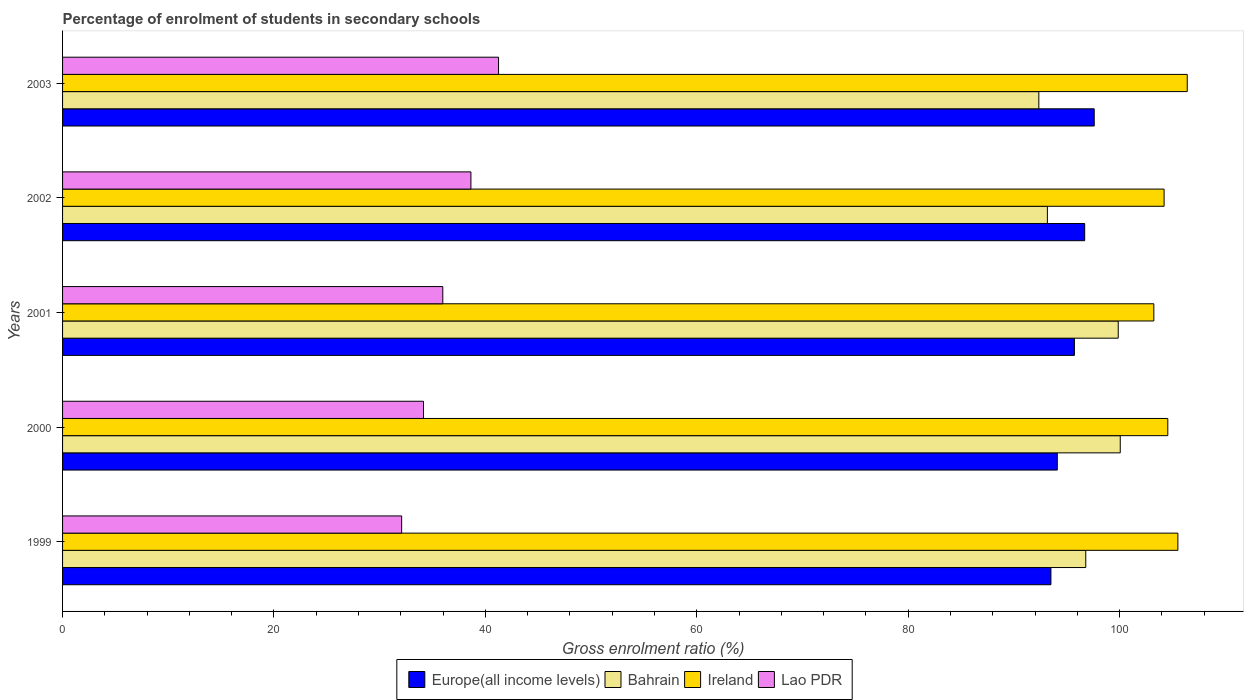How many different coloured bars are there?
Offer a terse response. 4. Are the number of bars per tick equal to the number of legend labels?
Keep it short and to the point. Yes. Are the number of bars on each tick of the Y-axis equal?
Offer a terse response. Yes. In how many cases, is the number of bars for a given year not equal to the number of legend labels?
Provide a succinct answer. 0. What is the percentage of students enrolled in secondary schools in Europe(all income levels) in 2000?
Ensure brevity in your answer.  94.1. Across all years, what is the maximum percentage of students enrolled in secondary schools in Lao PDR?
Provide a succinct answer. 41.24. Across all years, what is the minimum percentage of students enrolled in secondary schools in Europe(all income levels)?
Keep it short and to the point. 93.5. What is the total percentage of students enrolled in secondary schools in Europe(all income levels) in the graph?
Your answer should be compact. 477.61. What is the difference between the percentage of students enrolled in secondary schools in Bahrain in 1999 and that in 2003?
Your answer should be compact. 4.44. What is the difference between the percentage of students enrolled in secondary schools in Ireland in 2000 and the percentage of students enrolled in secondary schools in Europe(all income levels) in 1999?
Offer a terse response. 11.06. What is the average percentage of students enrolled in secondary schools in Ireland per year?
Your answer should be compact. 104.78. In the year 1999, what is the difference between the percentage of students enrolled in secondary schools in Ireland and percentage of students enrolled in secondary schools in Bahrain?
Ensure brevity in your answer.  8.71. In how many years, is the percentage of students enrolled in secondary schools in Europe(all income levels) greater than 64 %?
Provide a short and direct response. 5. What is the ratio of the percentage of students enrolled in secondary schools in Europe(all income levels) in 2000 to that in 2001?
Ensure brevity in your answer.  0.98. Is the percentage of students enrolled in secondary schools in Lao PDR in 1999 less than that in 2003?
Offer a very short reply. Yes. Is the difference between the percentage of students enrolled in secondary schools in Ireland in 2001 and 2003 greater than the difference between the percentage of students enrolled in secondary schools in Bahrain in 2001 and 2003?
Offer a terse response. No. What is the difference between the highest and the second highest percentage of students enrolled in secondary schools in Europe(all income levels)?
Your answer should be very brief. 0.9. What is the difference between the highest and the lowest percentage of students enrolled in secondary schools in Lao PDR?
Ensure brevity in your answer.  9.16. In how many years, is the percentage of students enrolled in secondary schools in Europe(all income levels) greater than the average percentage of students enrolled in secondary schools in Europe(all income levels) taken over all years?
Provide a short and direct response. 3. Is it the case that in every year, the sum of the percentage of students enrolled in secondary schools in Bahrain and percentage of students enrolled in secondary schools in Lao PDR is greater than the sum of percentage of students enrolled in secondary schools in Europe(all income levels) and percentage of students enrolled in secondary schools in Ireland?
Provide a succinct answer. No. What does the 4th bar from the top in 2000 represents?
Your response must be concise. Europe(all income levels). What does the 3rd bar from the bottom in 2003 represents?
Keep it short and to the point. Ireland. Is it the case that in every year, the sum of the percentage of students enrolled in secondary schools in Ireland and percentage of students enrolled in secondary schools in Bahrain is greater than the percentage of students enrolled in secondary schools in Lao PDR?
Provide a succinct answer. Yes. How many years are there in the graph?
Offer a very short reply. 5. What is the difference between two consecutive major ticks on the X-axis?
Your response must be concise. 20. Does the graph contain any zero values?
Offer a very short reply. No. How many legend labels are there?
Provide a short and direct response. 4. How are the legend labels stacked?
Keep it short and to the point. Horizontal. What is the title of the graph?
Offer a very short reply. Percentage of enrolment of students in secondary schools. What is the label or title of the Y-axis?
Your answer should be very brief. Years. What is the Gross enrolment ratio (%) of Europe(all income levels) in 1999?
Make the answer very short. 93.5. What is the Gross enrolment ratio (%) in Bahrain in 1999?
Provide a short and direct response. 96.8. What is the Gross enrolment ratio (%) in Ireland in 1999?
Offer a terse response. 105.51. What is the Gross enrolment ratio (%) of Lao PDR in 1999?
Make the answer very short. 32.08. What is the Gross enrolment ratio (%) of Europe(all income levels) in 2000?
Ensure brevity in your answer.  94.1. What is the Gross enrolment ratio (%) in Bahrain in 2000?
Your answer should be very brief. 100.06. What is the Gross enrolment ratio (%) in Ireland in 2000?
Give a very brief answer. 104.56. What is the Gross enrolment ratio (%) in Lao PDR in 2000?
Offer a terse response. 34.14. What is the Gross enrolment ratio (%) of Europe(all income levels) in 2001?
Offer a terse response. 95.72. What is the Gross enrolment ratio (%) of Bahrain in 2001?
Your answer should be compact. 99.87. What is the Gross enrolment ratio (%) in Ireland in 2001?
Your answer should be very brief. 103.23. What is the Gross enrolment ratio (%) of Lao PDR in 2001?
Offer a very short reply. 35.97. What is the Gross enrolment ratio (%) of Europe(all income levels) in 2002?
Ensure brevity in your answer.  96.69. What is the Gross enrolment ratio (%) of Bahrain in 2002?
Offer a terse response. 93.16. What is the Gross enrolment ratio (%) of Ireland in 2002?
Offer a terse response. 104.2. What is the Gross enrolment ratio (%) of Lao PDR in 2002?
Ensure brevity in your answer.  38.63. What is the Gross enrolment ratio (%) in Europe(all income levels) in 2003?
Ensure brevity in your answer.  97.59. What is the Gross enrolment ratio (%) in Bahrain in 2003?
Offer a very short reply. 92.35. What is the Gross enrolment ratio (%) of Ireland in 2003?
Offer a very short reply. 106.4. What is the Gross enrolment ratio (%) in Lao PDR in 2003?
Your answer should be very brief. 41.24. Across all years, what is the maximum Gross enrolment ratio (%) in Europe(all income levels)?
Your answer should be compact. 97.59. Across all years, what is the maximum Gross enrolment ratio (%) of Bahrain?
Your response must be concise. 100.06. Across all years, what is the maximum Gross enrolment ratio (%) of Ireland?
Your answer should be compact. 106.4. Across all years, what is the maximum Gross enrolment ratio (%) in Lao PDR?
Offer a terse response. 41.24. Across all years, what is the minimum Gross enrolment ratio (%) in Europe(all income levels)?
Offer a very short reply. 93.5. Across all years, what is the minimum Gross enrolment ratio (%) in Bahrain?
Provide a short and direct response. 92.35. Across all years, what is the minimum Gross enrolment ratio (%) of Ireland?
Make the answer very short. 103.23. Across all years, what is the minimum Gross enrolment ratio (%) of Lao PDR?
Ensure brevity in your answer.  32.08. What is the total Gross enrolment ratio (%) in Europe(all income levels) in the graph?
Give a very brief answer. 477.61. What is the total Gross enrolment ratio (%) of Bahrain in the graph?
Make the answer very short. 482.24. What is the total Gross enrolment ratio (%) of Ireland in the graph?
Your answer should be very brief. 523.9. What is the total Gross enrolment ratio (%) of Lao PDR in the graph?
Offer a terse response. 182.07. What is the difference between the Gross enrolment ratio (%) in Europe(all income levels) in 1999 and that in 2000?
Your answer should be very brief. -0.6. What is the difference between the Gross enrolment ratio (%) of Bahrain in 1999 and that in 2000?
Offer a terse response. -3.26. What is the difference between the Gross enrolment ratio (%) in Ireland in 1999 and that in 2000?
Your answer should be very brief. 0.95. What is the difference between the Gross enrolment ratio (%) in Lao PDR in 1999 and that in 2000?
Ensure brevity in your answer.  -2.07. What is the difference between the Gross enrolment ratio (%) in Europe(all income levels) in 1999 and that in 2001?
Your response must be concise. -2.22. What is the difference between the Gross enrolment ratio (%) in Bahrain in 1999 and that in 2001?
Your response must be concise. -3.07. What is the difference between the Gross enrolment ratio (%) in Ireland in 1999 and that in 2001?
Your response must be concise. 2.27. What is the difference between the Gross enrolment ratio (%) of Lao PDR in 1999 and that in 2001?
Offer a terse response. -3.89. What is the difference between the Gross enrolment ratio (%) in Europe(all income levels) in 1999 and that in 2002?
Offer a very short reply. -3.19. What is the difference between the Gross enrolment ratio (%) in Bahrain in 1999 and that in 2002?
Make the answer very short. 3.63. What is the difference between the Gross enrolment ratio (%) of Ireland in 1999 and that in 2002?
Make the answer very short. 1.3. What is the difference between the Gross enrolment ratio (%) in Lao PDR in 1999 and that in 2002?
Your answer should be compact. -6.55. What is the difference between the Gross enrolment ratio (%) in Europe(all income levels) in 1999 and that in 2003?
Keep it short and to the point. -4.09. What is the difference between the Gross enrolment ratio (%) of Bahrain in 1999 and that in 2003?
Provide a succinct answer. 4.44. What is the difference between the Gross enrolment ratio (%) of Ireland in 1999 and that in 2003?
Your answer should be very brief. -0.89. What is the difference between the Gross enrolment ratio (%) in Lao PDR in 1999 and that in 2003?
Make the answer very short. -9.16. What is the difference between the Gross enrolment ratio (%) of Europe(all income levels) in 2000 and that in 2001?
Keep it short and to the point. -1.62. What is the difference between the Gross enrolment ratio (%) of Bahrain in 2000 and that in 2001?
Make the answer very short. 0.19. What is the difference between the Gross enrolment ratio (%) in Ireland in 2000 and that in 2001?
Give a very brief answer. 1.32. What is the difference between the Gross enrolment ratio (%) in Lao PDR in 2000 and that in 2001?
Your answer should be very brief. -1.83. What is the difference between the Gross enrolment ratio (%) of Europe(all income levels) in 2000 and that in 2002?
Offer a terse response. -2.59. What is the difference between the Gross enrolment ratio (%) in Bahrain in 2000 and that in 2002?
Your response must be concise. 6.89. What is the difference between the Gross enrolment ratio (%) of Ireland in 2000 and that in 2002?
Your response must be concise. 0.35. What is the difference between the Gross enrolment ratio (%) of Lao PDR in 2000 and that in 2002?
Provide a short and direct response. -4.49. What is the difference between the Gross enrolment ratio (%) in Europe(all income levels) in 2000 and that in 2003?
Give a very brief answer. -3.49. What is the difference between the Gross enrolment ratio (%) of Bahrain in 2000 and that in 2003?
Your answer should be compact. 7.7. What is the difference between the Gross enrolment ratio (%) of Ireland in 2000 and that in 2003?
Your answer should be compact. -1.84. What is the difference between the Gross enrolment ratio (%) of Lao PDR in 2000 and that in 2003?
Ensure brevity in your answer.  -7.1. What is the difference between the Gross enrolment ratio (%) in Europe(all income levels) in 2001 and that in 2002?
Give a very brief answer. -0.97. What is the difference between the Gross enrolment ratio (%) in Bahrain in 2001 and that in 2002?
Make the answer very short. 6.7. What is the difference between the Gross enrolment ratio (%) of Ireland in 2001 and that in 2002?
Give a very brief answer. -0.97. What is the difference between the Gross enrolment ratio (%) in Lao PDR in 2001 and that in 2002?
Make the answer very short. -2.66. What is the difference between the Gross enrolment ratio (%) of Europe(all income levels) in 2001 and that in 2003?
Give a very brief answer. -1.87. What is the difference between the Gross enrolment ratio (%) in Bahrain in 2001 and that in 2003?
Your answer should be very brief. 7.51. What is the difference between the Gross enrolment ratio (%) in Ireland in 2001 and that in 2003?
Provide a short and direct response. -3.16. What is the difference between the Gross enrolment ratio (%) in Lao PDR in 2001 and that in 2003?
Make the answer very short. -5.27. What is the difference between the Gross enrolment ratio (%) of Europe(all income levels) in 2002 and that in 2003?
Keep it short and to the point. -0.9. What is the difference between the Gross enrolment ratio (%) of Bahrain in 2002 and that in 2003?
Ensure brevity in your answer.  0.81. What is the difference between the Gross enrolment ratio (%) of Ireland in 2002 and that in 2003?
Provide a short and direct response. -2.19. What is the difference between the Gross enrolment ratio (%) in Lao PDR in 2002 and that in 2003?
Your response must be concise. -2.61. What is the difference between the Gross enrolment ratio (%) of Europe(all income levels) in 1999 and the Gross enrolment ratio (%) of Bahrain in 2000?
Your answer should be compact. -6.56. What is the difference between the Gross enrolment ratio (%) of Europe(all income levels) in 1999 and the Gross enrolment ratio (%) of Ireland in 2000?
Offer a terse response. -11.06. What is the difference between the Gross enrolment ratio (%) of Europe(all income levels) in 1999 and the Gross enrolment ratio (%) of Lao PDR in 2000?
Ensure brevity in your answer.  59.36. What is the difference between the Gross enrolment ratio (%) in Bahrain in 1999 and the Gross enrolment ratio (%) in Ireland in 2000?
Your response must be concise. -7.76. What is the difference between the Gross enrolment ratio (%) in Bahrain in 1999 and the Gross enrolment ratio (%) in Lao PDR in 2000?
Offer a terse response. 62.65. What is the difference between the Gross enrolment ratio (%) of Ireland in 1999 and the Gross enrolment ratio (%) of Lao PDR in 2000?
Make the answer very short. 71.36. What is the difference between the Gross enrolment ratio (%) of Europe(all income levels) in 1999 and the Gross enrolment ratio (%) of Bahrain in 2001?
Offer a very short reply. -6.37. What is the difference between the Gross enrolment ratio (%) in Europe(all income levels) in 1999 and the Gross enrolment ratio (%) in Ireland in 2001?
Offer a terse response. -9.73. What is the difference between the Gross enrolment ratio (%) in Europe(all income levels) in 1999 and the Gross enrolment ratio (%) in Lao PDR in 2001?
Make the answer very short. 57.53. What is the difference between the Gross enrolment ratio (%) in Bahrain in 1999 and the Gross enrolment ratio (%) in Ireland in 2001?
Offer a terse response. -6.44. What is the difference between the Gross enrolment ratio (%) in Bahrain in 1999 and the Gross enrolment ratio (%) in Lao PDR in 2001?
Offer a very short reply. 60.83. What is the difference between the Gross enrolment ratio (%) of Ireland in 1999 and the Gross enrolment ratio (%) of Lao PDR in 2001?
Your answer should be very brief. 69.54. What is the difference between the Gross enrolment ratio (%) in Europe(all income levels) in 1999 and the Gross enrolment ratio (%) in Bahrain in 2002?
Your answer should be compact. 0.34. What is the difference between the Gross enrolment ratio (%) in Europe(all income levels) in 1999 and the Gross enrolment ratio (%) in Ireland in 2002?
Offer a very short reply. -10.7. What is the difference between the Gross enrolment ratio (%) in Europe(all income levels) in 1999 and the Gross enrolment ratio (%) in Lao PDR in 2002?
Your answer should be very brief. 54.87. What is the difference between the Gross enrolment ratio (%) in Bahrain in 1999 and the Gross enrolment ratio (%) in Ireland in 2002?
Ensure brevity in your answer.  -7.41. What is the difference between the Gross enrolment ratio (%) in Bahrain in 1999 and the Gross enrolment ratio (%) in Lao PDR in 2002?
Your answer should be compact. 58.17. What is the difference between the Gross enrolment ratio (%) in Ireland in 1999 and the Gross enrolment ratio (%) in Lao PDR in 2002?
Give a very brief answer. 66.88. What is the difference between the Gross enrolment ratio (%) of Europe(all income levels) in 1999 and the Gross enrolment ratio (%) of Bahrain in 2003?
Keep it short and to the point. 1.15. What is the difference between the Gross enrolment ratio (%) of Europe(all income levels) in 1999 and the Gross enrolment ratio (%) of Ireland in 2003?
Offer a very short reply. -12.9. What is the difference between the Gross enrolment ratio (%) of Europe(all income levels) in 1999 and the Gross enrolment ratio (%) of Lao PDR in 2003?
Provide a succinct answer. 52.26. What is the difference between the Gross enrolment ratio (%) of Bahrain in 1999 and the Gross enrolment ratio (%) of Ireland in 2003?
Ensure brevity in your answer.  -9.6. What is the difference between the Gross enrolment ratio (%) in Bahrain in 1999 and the Gross enrolment ratio (%) in Lao PDR in 2003?
Provide a short and direct response. 55.55. What is the difference between the Gross enrolment ratio (%) in Ireland in 1999 and the Gross enrolment ratio (%) in Lao PDR in 2003?
Give a very brief answer. 64.27. What is the difference between the Gross enrolment ratio (%) in Europe(all income levels) in 2000 and the Gross enrolment ratio (%) in Bahrain in 2001?
Your answer should be compact. -5.76. What is the difference between the Gross enrolment ratio (%) in Europe(all income levels) in 2000 and the Gross enrolment ratio (%) in Ireland in 2001?
Your answer should be very brief. -9.13. What is the difference between the Gross enrolment ratio (%) of Europe(all income levels) in 2000 and the Gross enrolment ratio (%) of Lao PDR in 2001?
Ensure brevity in your answer.  58.13. What is the difference between the Gross enrolment ratio (%) of Bahrain in 2000 and the Gross enrolment ratio (%) of Ireland in 2001?
Offer a very short reply. -3.18. What is the difference between the Gross enrolment ratio (%) of Bahrain in 2000 and the Gross enrolment ratio (%) of Lao PDR in 2001?
Provide a succinct answer. 64.09. What is the difference between the Gross enrolment ratio (%) in Ireland in 2000 and the Gross enrolment ratio (%) in Lao PDR in 2001?
Ensure brevity in your answer.  68.58. What is the difference between the Gross enrolment ratio (%) of Europe(all income levels) in 2000 and the Gross enrolment ratio (%) of Bahrain in 2002?
Offer a terse response. 0.94. What is the difference between the Gross enrolment ratio (%) in Europe(all income levels) in 2000 and the Gross enrolment ratio (%) in Ireland in 2002?
Offer a terse response. -10.1. What is the difference between the Gross enrolment ratio (%) in Europe(all income levels) in 2000 and the Gross enrolment ratio (%) in Lao PDR in 2002?
Offer a very short reply. 55.47. What is the difference between the Gross enrolment ratio (%) in Bahrain in 2000 and the Gross enrolment ratio (%) in Ireland in 2002?
Your answer should be compact. -4.15. What is the difference between the Gross enrolment ratio (%) of Bahrain in 2000 and the Gross enrolment ratio (%) of Lao PDR in 2002?
Your answer should be compact. 61.43. What is the difference between the Gross enrolment ratio (%) of Ireland in 2000 and the Gross enrolment ratio (%) of Lao PDR in 2002?
Your response must be concise. 65.93. What is the difference between the Gross enrolment ratio (%) of Europe(all income levels) in 2000 and the Gross enrolment ratio (%) of Bahrain in 2003?
Provide a short and direct response. 1.75. What is the difference between the Gross enrolment ratio (%) of Europe(all income levels) in 2000 and the Gross enrolment ratio (%) of Ireland in 2003?
Your answer should be very brief. -12.29. What is the difference between the Gross enrolment ratio (%) in Europe(all income levels) in 2000 and the Gross enrolment ratio (%) in Lao PDR in 2003?
Give a very brief answer. 52.86. What is the difference between the Gross enrolment ratio (%) of Bahrain in 2000 and the Gross enrolment ratio (%) of Ireland in 2003?
Offer a very short reply. -6.34. What is the difference between the Gross enrolment ratio (%) of Bahrain in 2000 and the Gross enrolment ratio (%) of Lao PDR in 2003?
Keep it short and to the point. 58.81. What is the difference between the Gross enrolment ratio (%) in Ireland in 2000 and the Gross enrolment ratio (%) in Lao PDR in 2003?
Keep it short and to the point. 63.31. What is the difference between the Gross enrolment ratio (%) in Europe(all income levels) in 2001 and the Gross enrolment ratio (%) in Bahrain in 2002?
Offer a very short reply. 2.56. What is the difference between the Gross enrolment ratio (%) of Europe(all income levels) in 2001 and the Gross enrolment ratio (%) of Ireland in 2002?
Provide a short and direct response. -8.48. What is the difference between the Gross enrolment ratio (%) in Europe(all income levels) in 2001 and the Gross enrolment ratio (%) in Lao PDR in 2002?
Ensure brevity in your answer.  57.09. What is the difference between the Gross enrolment ratio (%) in Bahrain in 2001 and the Gross enrolment ratio (%) in Ireland in 2002?
Keep it short and to the point. -4.34. What is the difference between the Gross enrolment ratio (%) of Bahrain in 2001 and the Gross enrolment ratio (%) of Lao PDR in 2002?
Your answer should be very brief. 61.24. What is the difference between the Gross enrolment ratio (%) of Ireland in 2001 and the Gross enrolment ratio (%) of Lao PDR in 2002?
Keep it short and to the point. 64.6. What is the difference between the Gross enrolment ratio (%) of Europe(all income levels) in 2001 and the Gross enrolment ratio (%) of Bahrain in 2003?
Make the answer very short. 3.37. What is the difference between the Gross enrolment ratio (%) in Europe(all income levels) in 2001 and the Gross enrolment ratio (%) in Ireland in 2003?
Your answer should be very brief. -10.67. What is the difference between the Gross enrolment ratio (%) in Europe(all income levels) in 2001 and the Gross enrolment ratio (%) in Lao PDR in 2003?
Your answer should be very brief. 54.48. What is the difference between the Gross enrolment ratio (%) in Bahrain in 2001 and the Gross enrolment ratio (%) in Ireland in 2003?
Keep it short and to the point. -6.53. What is the difference between the Gross enrolment ratio (%) of Bahrain in 2001 and the Gross enrolment ratio (%) of Lao PDR in 2003?
Ensure brevity in your answer.  58.62. What is the difference between the Gross enrolment ratio (%) in Ireland in 2001 and the Gross enrolment ratio (%) in Lao PDR in 2003?
Ensure brevity in your answer.  61.99. What is the difference between the Gross enrolment ratio (%) in Europe(all income levels) in 2002 and the Gross enrolment ratio (%) in Bahrain in 2003?
Provide a succinct answer. 4.34. What is the difference between the Gross enrolment ratio (%) in Europe(all income levels) in 2002 and the Gross enrolment ratio (%) in Ireland in 2003?
Your answer should be very brief. -9.7. What is the difference between the Gross enrolment ratio (%) of Europe(all income levels) in 2002 and the Gross enrolment ratio (%) of Lao PDR in 2003?
Keep it short and to the point. 55.45. What is the difference between the Gross enrolment ratio (%) of Bahrain in 2002 and the Gross enrolment ratio (%) of Ireland in 2003?
Make the answer very short. -13.23. What is the difference between the Gross enrolment ratio (%) of Bahrain in 2002 and the Gross enrolment ratio (%) of Lao PDR in 2003?
Offer a terse response. 51.92. What is the difference between the Gross enrolment ratio (%) of Ireland in 2002 and the Gross enrolment ratio (%) of Lao PDR in 2003?
Keep it short and to the point. 62.96. What is the average Gross enrolment ratio (%) in Europe(all income levels) per year?
Provide a short and direct response. 95.52. What is the average Gross enrolment ratio (%) of Bahrain per year?
Ensure brevity in your answer.  96.45. What is the average Gross enrolment ratio (%) of Ireland per year?
Your answer should be very brief. 104.78. What is the average Gross enrolment ratio (%) in Lao PDR per year?
Your response must be concise. 36.41. In the year 1999, what is the difference between the Gross enrolment ratio (%) in Europe(all income levels) and Gross enrolment ratio (%) in Bahrain?
Your response must be concise. -3.3. In the year 1999, what is the difference between the Gross enrolment ratio (%) of Europe(all income levels) and Gross enrolment ratio (%) of Ireland?
Provide a succinct answer. -12.01. In the year 1999, what is the difference between the Gross enrolment ratio (%) in Europe(all income levels) and Gross enrolment ratio (%) in Lao PDR?
Offer a terse response. 61.42. In the year 1999, what is the difference between the Gross enrolment ratio (%) of Bahrain and Gross enrolment ratio (%) of Ireland?
Provide a short and direct response. -8.71. In the year 1999, what is the difference between the Gross enrolment ratio (%) of Bahrain and Gross enrolment ratio (%) of Lao PDR?
Provide a short and direct response. 64.72. In the year 1999, what is the difference between the Gross enrolment ratio (%) of Ireland and Gross enrolment ratio (%) of Lao PDR?
Ensure brevity in your answer.  73.43. In the year 2000, what is the difference between the Gross enrolment ratio (%) of Europe(all income levels) and Gross enrolment ratio (%) of Bahrain?
Provide a short and direct response. -5.95. In the year 2000, what is the difference between the Gross enrolment ratio (%) in Europe(all income levels) and Gross enrolment ratio (%) in Ireland?
Make the answer very short. -10.45. In the year 2000, what is the difference between the Gross enrolment ratio (%) of Europe(all income levels) and Gross enrolment ratio (%) of Lao PDR?
Make the answer very short. 59.96. In the year 2000, what is the difference between the Gross enrolment ratio (%) in Bahrain and Gross enrolment ratio (%) in Ireland?
Keep it short and to the point. -4.5. In the year 2000, what is the difference between the Gross enrolment ratio (%) in Bahrain and Gross enrolment ratio (%) in Lao PDR?
Provide a succinct answer. 65.91. In the year 2000, what is the difference between the Gross enrolment ratio (%) of Ireland and Gross enrolment ratio (%) of Lao PDR?
Your response must be concise. 70.41. In the year 2001, what is the difference between the Gross enrolment ratio (%) in Europe(all income levels) and Gross enrolment ratio (%) in Bahrain?
Keep it short and to the point. -4.15. In the year 2001, what is the difference between the Gross enrolment ratio (%) in Europe(all income levels) and Gross enrolment ratio (%) in Ireland?
Your response must be concise. -7.51. In the year 2001, what is the difference between the Gross enrolment ratio (%) in Europe(all income levels) and Gross enrolment ratio (%) in Lao PDR?
Make the answer very short. 59.75. In the year 2001, what is the difference between the Gross enrolment ratio (%) of Bahrain and Gross enrolment ratio (%) of Ireland?
Offer a very short reply. -3.37. In the year 2001, what is the difference between the Gross enrolment ratio (%) in Bahrain and Gross enrolment ratio (%) in Lao PDR?
Offer a terse response. 63.9. In the year 2001, what is the difference between the Gross enrolment ratio (%) of Ireland and Gross enrolment ratio (%) of Lao PDR?
Ensure brevity in your answer.  67.26. In the year 2002, what is the difference between the Gross enrolment ratio (%) in Europe(all income levels) and Gross enrolment ratio (%) in Bahrain?
Offer a very short reply. 3.53. In the year 2002, what is the difference between the Gross enrolment ratio (%) of Europe(all income levels) and Gross enrolment ratio (%) of Ireland?
Give a very brief answer. -7.51. In the year 2002, what is the difference between the Gross enrolment ratio (%) in Europe(all income levels) and Gross enrolment ratio (%) in Lao PDR?
Make the answer very short. 58.06. In the year 2002, what is the difference between the Gross enrolment ratio (%) of Bahrain and Gross enrolment ratio (%) of Ireland?
Give a very brief answer. -11.04. In the year 2002, what is the difference between the Gross enrolment ratio (%) in Bahrain and Gross enrolment ratio (%) in Lao PDR?
Give a very brief answer. 54.53. In the year 2002, what is the difference between the Gross enrolment ratio (%) of Ireland and Gross enrolment ratio (%) of Lao PDR?
Offer a very short reply. 65.57. In the year 2003, what is the difference between the Gross enrolment ratio (%) in Europe(all income levels) and Gross enrolment ratio (%) in Bahrain?
Your response must be concise. 5.24. In the year 2003, what is the difference between the Gross enrolment ratio (%) of Europe(all income levels) and Gross enrolment ratio (%) of Ireland?
Offer a terse response. -8.8. In the year 2003, what is the difference between the Gross enrolment ratio (%) of Europe(all income levels) and Gross enrolment ratio (%) of Lao PDR?
Ensure brevity in your answer.  56.35. In the year 2003, what is the difference between the Gross enrolment ratio (%) in Bahrain and Gross enrolment ratio (%) in Ireland?
Ensure brevity in your answer.  -14.04. In the year 2003, what is the difference between the Gross enrolment ratio (%) of Bahrain and Gross enrolment ratio (%) of Lao PDR?
Offer a very short reply. 51.11. In the year 2003, what is the difference between the Gross enrolment ratio (%) in Ireland and Gross enrolment ratio (%) in Lao PDR?
Your answer should be compact. 65.15. What is the ratio of the Gross enrolment ratio (%) of Europe(all income levels) in 1999 to that in 2000?
Your answer should be very brief. 0.99. What is the ratio of the Gross enrolment ratio (%) in Bahrain in 1999 to that in 2000?
Offer a very short reply. 0.97. What is the ratio of the Gross enrolment ratio (%) in Ireland in 1999 to that in 2000?
Ensure brevity in your answer.  1.01. What is the ratio of the Gross enrolment ratio (%) in Lao PDR in 1999 to that in 2000?
Provide a succinct answer. 0.94. What is the ratio of the Gross enrolment ratio (%) in Europe(all income levels) in 1999 to that in 2001?
Ensure brevity in your answer.  0.98. What is the ratio of the Gross enrolment ratio (%) of Bahrain in 1999 to that in 2001?
Give a very brief answer. 0.97. What is the ratio of the Gross enrolment ratio (%) in Lao PDR in 1999 to that in 2001?
Give a very brief answer. 0.89. What is the ratio of the Gross enrolment ratio (%) of Europe(all income levels) in 1999 to that in 2002?
Give a very brief answer. 0.97. What is the ratio of the Gross enrolment ratio (%) in Bahrain in 1999 to that in 2002?
Make the answer very short. 1.04. What is the ratio of the Gross enrolment ratio (%) in Ireland in 1999 to that in 2002?
Give a very brief answer. 1.01. What is the ratio of the Gross enrolment ratio (%) in Lao PDR in 1999 to that in 2002?
Offer a very short reply. 0.83. What is the ratio of the Gross enrolment ratio (%) of Europe(all income levels) in 1999 to that in 2003?
Ensure brevity in your answer.  0.96. What is the ratio of the Gross enrolment ratio (%) in Bahrain in 1999 to that in 2003?
Offer a terse response. 1.05. What is the ratio of the Gross enrolment ratio (%) in Ireland in 1999 to that in 2003?
Your answer should be compact. 0.99. What is the ratio of the Gross enrolment ratio (%) in Lao PDR in 1999 to that in 2003?
Make the answer very short. 0.78. What is the ratio of the Gross enrolment ratio (%) of Europe(all income levels) in 2000 to that in 2001?
Make the answer very short. 0.98. What is the ratio of the Gross enrolment ratio (%) in Bahrain in 2000 to that in 2001?
Your response must be concise. 1. What is the ratio of the Gross enrolment ratio (%) of Ireland in 2000 to that in 2001?
Offer a terse response. 1.01. What is the ratio of the Gross enrolment ratio (%) in Lao PDR in 2000 to that in 2001?
Your response must be concise. 0.95. What is the ratio of the Gross enrolment ratio (%) in Europe(all income levels) in 2000 to that in 2002?
Offer a terse response. 0.97. What is the ratio of the Gross enrolment ratio (%) of Bahrain in 2000 to that in 2002?
Your response must be concise. 1.07. What is the ratio of the Gross enrolment ratio (%) of Ireland in 2000 to that in 2002?
Provide a succinct answer. 1. What is the ratio of the Gross enrolment ratio (%) in Lao PDR in 2000 to that in 2002?
Give a very brief answer. 0.88. What is the ratio of the Gross enrolment ratio (%) in Europe(all income levels) in 2000 to that in 2003?
Make the answer very short. 0.96. What is the ratio of the Gross enrolment ratio (%) of Bahrain in 2000 to that in 2003?
Keep it short and to the point. 1.08. What is the ratio of the Gross enrolment ratio (%) of Ireland in 2000 to that in 2003?
Give a very brief answer. 0.98. What is the ratio of the Gross enrolment ratio (%) in Lao PDR in 2000 to that in 2003?
Your answer should be very brief. 0.83. What is the ratio of the Gross enrolment ratio (%) of Europe(all income levels) in 2001 to that in 2002?
Make the answer very short. 0.99. What is the ratio of the Gross enrolment ratio (%) in Bahrain in 2001 to that in 2002?
Keep it short and to the point. 1.07. What is the ratio of the Gross enrolment ratio (%) in Lao PDR in 2001 to that in 2002?
Ensure brevity in your answer.  0.93. What is the ratio of the Gross enrolment ratio (%) of Europe(all income levels) in 2001 to that in 2003?
Your answer should be very brief. 0.98. What is the ratio of the Gross enrolment ratio (%) of Bahrain in 2001 to that in 2003?
Your answer should be compact. 1.08. What is the ratio of the Gross enrolment ratio (%) of Ireland in 2001 to that in 2003?
Your response must be concise. 0.97. What is the ratio of the Gross enrolment ratio (%) in Lao PDR in 2001 to that in 2003?
Your answer should be very brief. 0.87. What is the ratio of the Gross enrolment ratio (%) of Europe(all income levels) in 2002 to that in 2003?
Your answer should be very brief. 0.99. What is the ratio of the Gross enrolment ratio (%) of Bahrain in 2002 to that in 2003?
Provide a succinct answer. 1.01. What is the ratio of the Gross enrolment ratio (%) in Ireland in 2002 to that in 2003?
Offer a very short reply. 0.98. What is the ratio of the Gross enrolment ratio (%) in Lao PDR in 2002 to that in 2003?
Give a very brief answer. 0.94. What is the difference between the highest and the second highest Gross enrolment ratio (%) of Europe(all income levels)?
Keep it short and to the point. 0.9. What is the difference between the highest and the second highest Gross enrolment ratio (%) of Bahrain?
Keep it short and to the point. 0.19. What is the difference between the highest and the second highest Gross enrolment ratio (%) in Ireland?
Your answer should be compact. 0.89. What is the difference between the highest and the second highest Gross enrolment ratio (%) of Lao PDR?
Your answer should be compact. 2.61. What is the difference between the highest and the lowest Gross enrolment ratio (%) in Europe(all income levels)?
Ensure brevity in your answer.  4.09. What is the difference between the highest and the lowest Gross enrolment ratio (%) in Bahrain?
Give a very brief answer. 7.7. What is the difference between the highest and the lowest Gross enrolment ratio (%) in Ireland?
Provide a succinct answer. 3.16. What is the difference between the highest and the lowest Gross enrolment ratio (%) in Lao PDR?
Your answer should be compact. 9.16. 